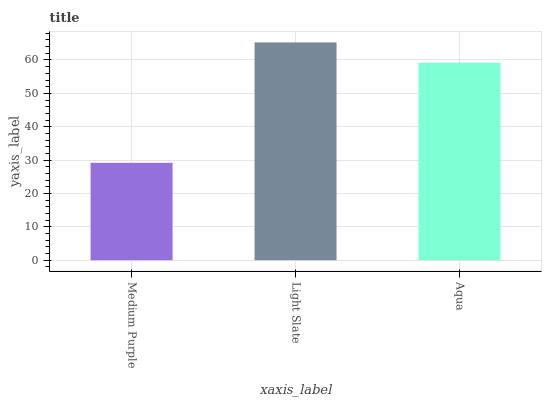Is Medium Purple the minimum?
Answer yes or no. Yes. Is Light Slate the maximum?
Answer yes or no. Yes. Is Aqua the minimum?
Answer yes or no. No. Is Aqua the maximum?
Answer yes or no. No. Is Light Slate greater than Aqua?
Answer yes or no. Yes. Is Aqua less than Light Slate?
Answer yes or no. Yes. Is Aqua greater than Light Slate?
Answer yes or no. No. Is Light Slate less than Aqua?
Answer yes or no. No. Is Aqua the high median?
Answer yes or no. Yes. Is Aqua the low median?
Answer yes or no. Yes. Is Light Slate the high median?
Answer yes or no. No. Is Light Slate the low median?
Answer yes or no. No. 